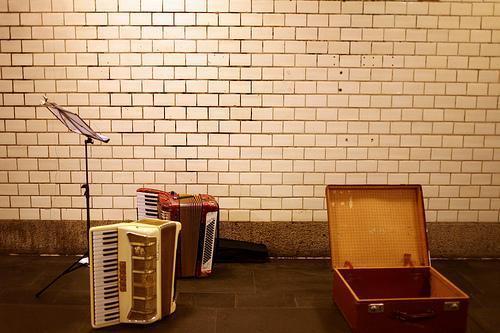How many accordions are shown?
Give a very brief answer. 2. 